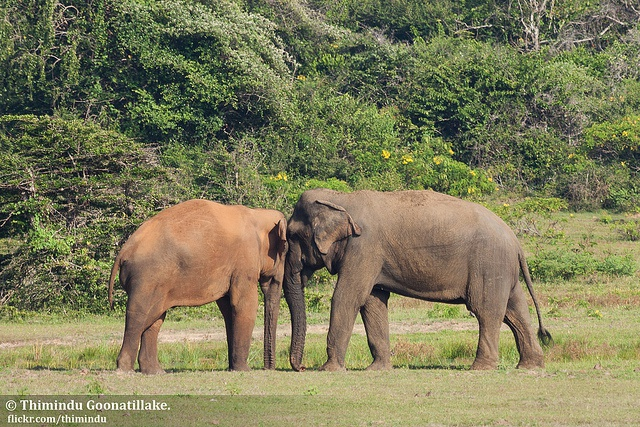Describe the objects in this image and their specific colors. I can see elephant in olive, gray, tan, and black tones and elephant in olive, gray, and tan tones in this image. 